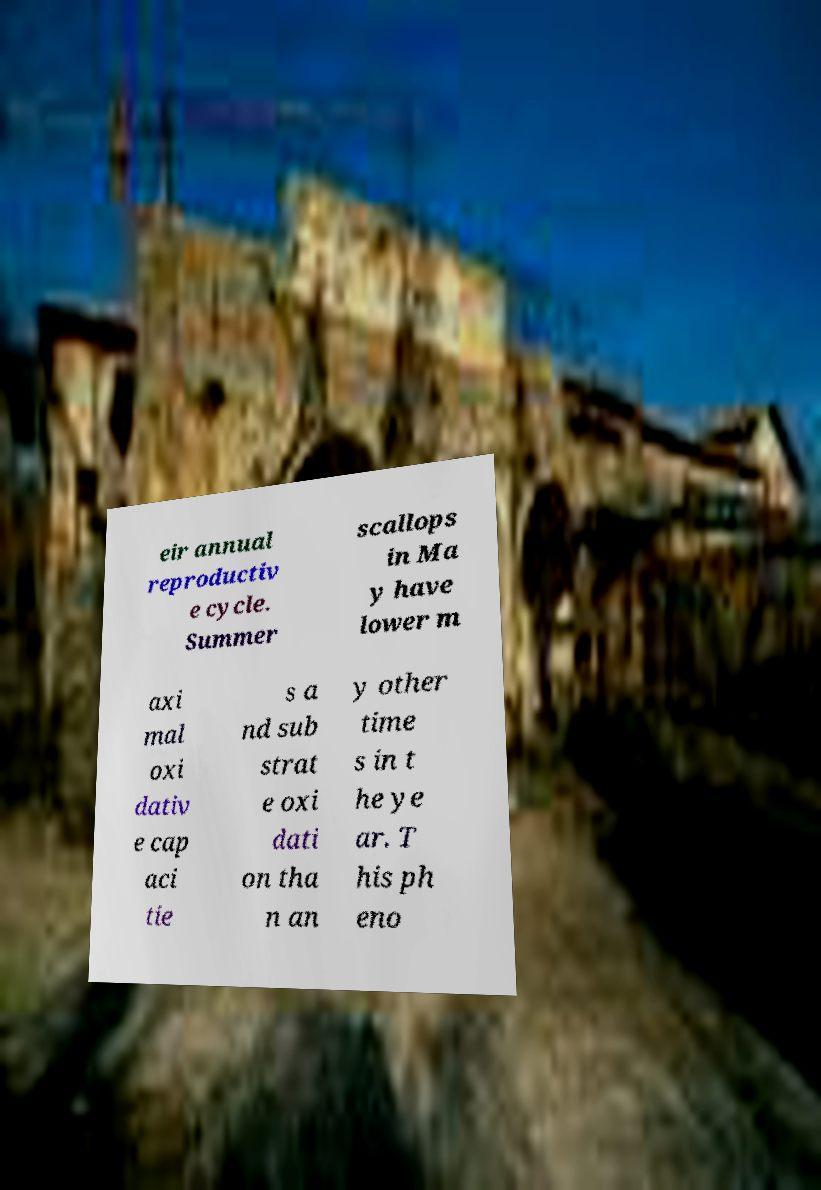Could you extract and type out the text from this image? eir annual reproductiv e cycle. Summer scallops in Ma y have lower m axi mal oxi dativ e cap aci tie s a nd sub strat e oxi dati on tha n an y other time s in t he ye ar. T his ph eno 